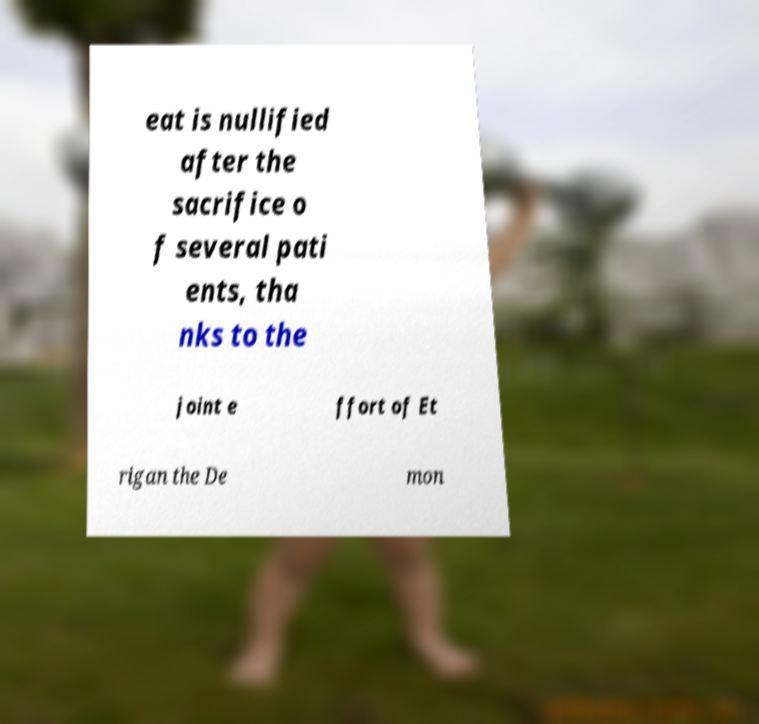I need the written content from this picture converted into text. Can you do that? eat is nullified after the sacrifice o f several pati ents, tha nks to the joint e ffort of Et rigan the De mon 